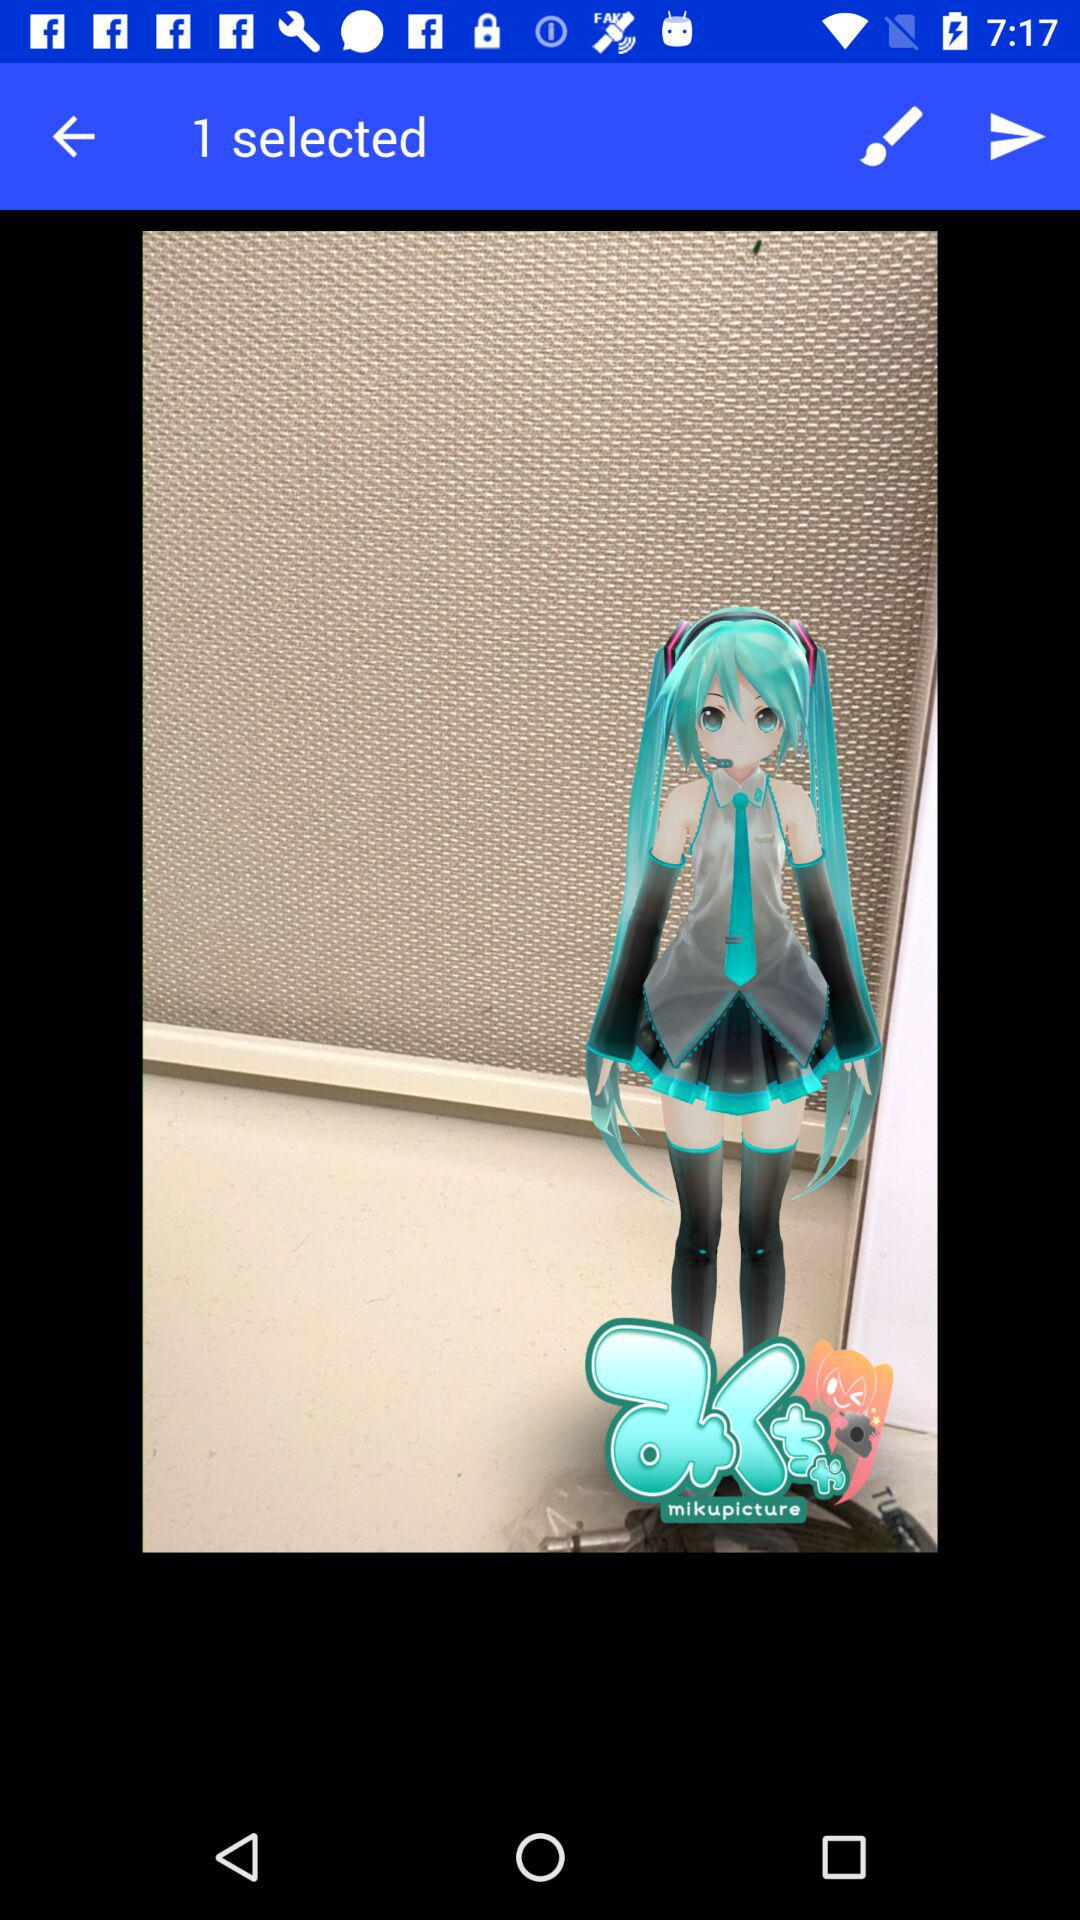How many new messages are there?
When the provided information is insufficient, respond with <no answer>. <no answer> 